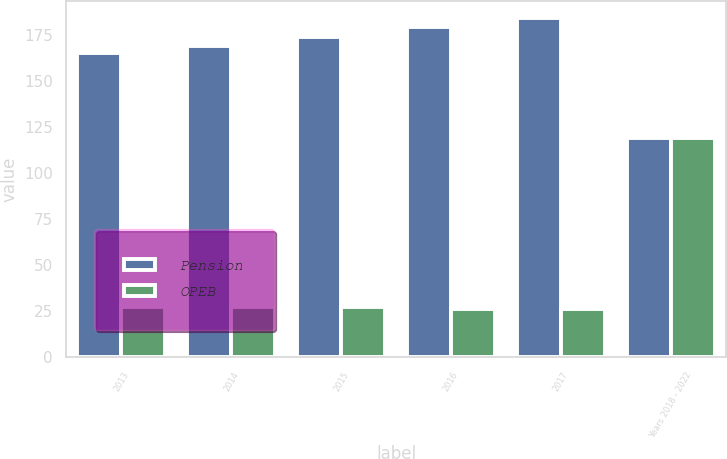Convert chart. <chart><loc_0><loc_0><loc_500><loc_500><stacked_bar_chart><ecel><fcel>2013<fcel>2014<fcel>2015<fcel>2016<fcel>2017<fcel>Years 2018 - 2022<nl><fcel>Pension<fcel>165<fcel>169<fcel>174<fcel>179<fcel>184<fcel>119<nl><fcel>OPEB<fcel>27<fcel>27<fcel>27<fcel>26<fcel>26<fcel>119<nl></chart> 